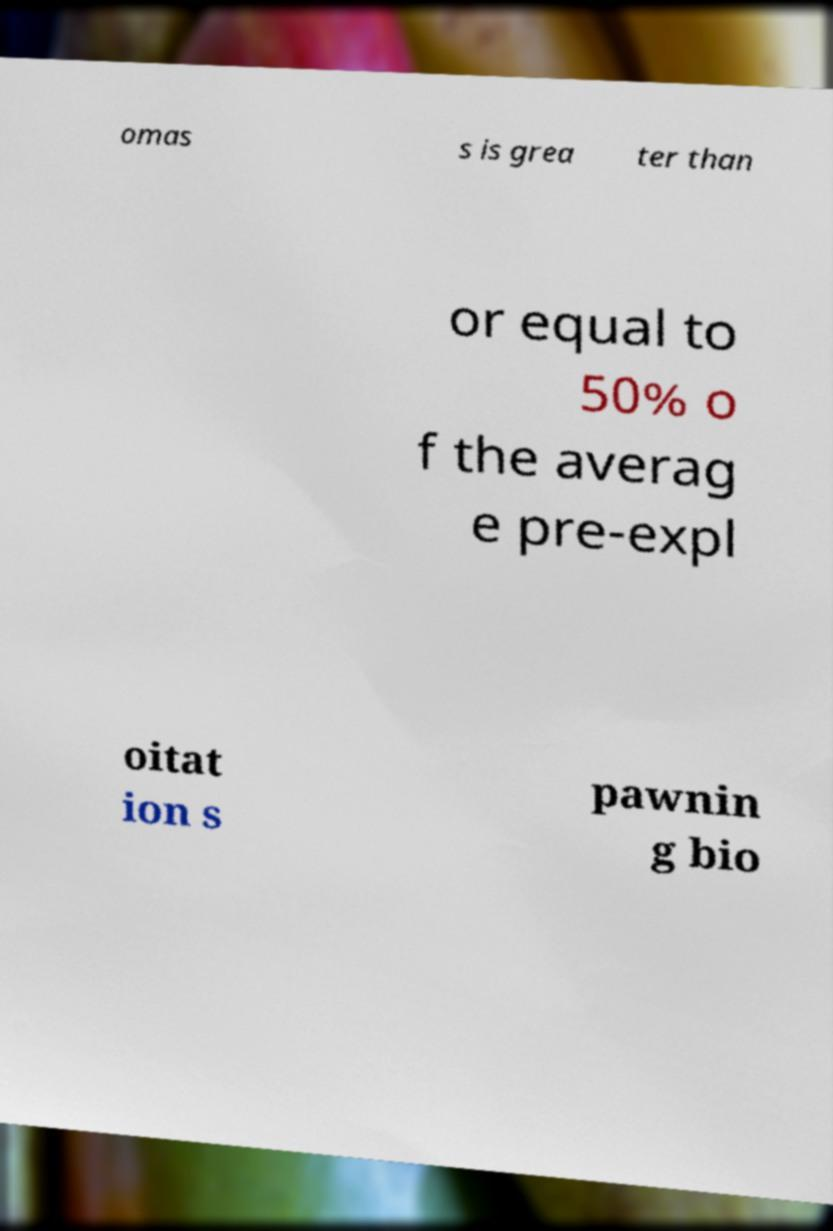There's text embedded in this image that I need extracted. Can you transcribe it verbatim? omas s is grea ter than or equal to 50% o f the averag e pre-expl oitat ion s pawnin g bio 